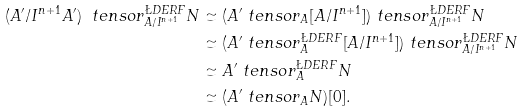Convert formula to latex. <formula><loc_0><loc_0><loc_500><loc_500>( A ^ { \prime } / I ^ { n + 1 } A ^ { \prime } ) \ t e n s o r ^ { \L D E R F } _ { A / I ^ { n + 1 } } N & \simeq ( A ^ { \prime } \ t e n s o r _ { A } [ A / I ^ { n + 1 } ] ) \ t e n s o r _ { A / I ^ { n + 1 } } ^ { \L D E R F } N \\ & \simeq ( A ^ { \prime } \ t e n s o r _ { A } ^ { \L D E R F } [ A / I ^ { n + 1 } ] ) \ t e n s o r _ { A / I ^ { n + 1 } } ^ { \L D E R F } N \\ & \simeq A ^ { \prime } \ t e n s o r _ { A } ^ { \L D E R F } N \\ & \simeq ( A ^ { \prime } \ t e n s o r _ { A } N ) [ 0 ] .</formula> 